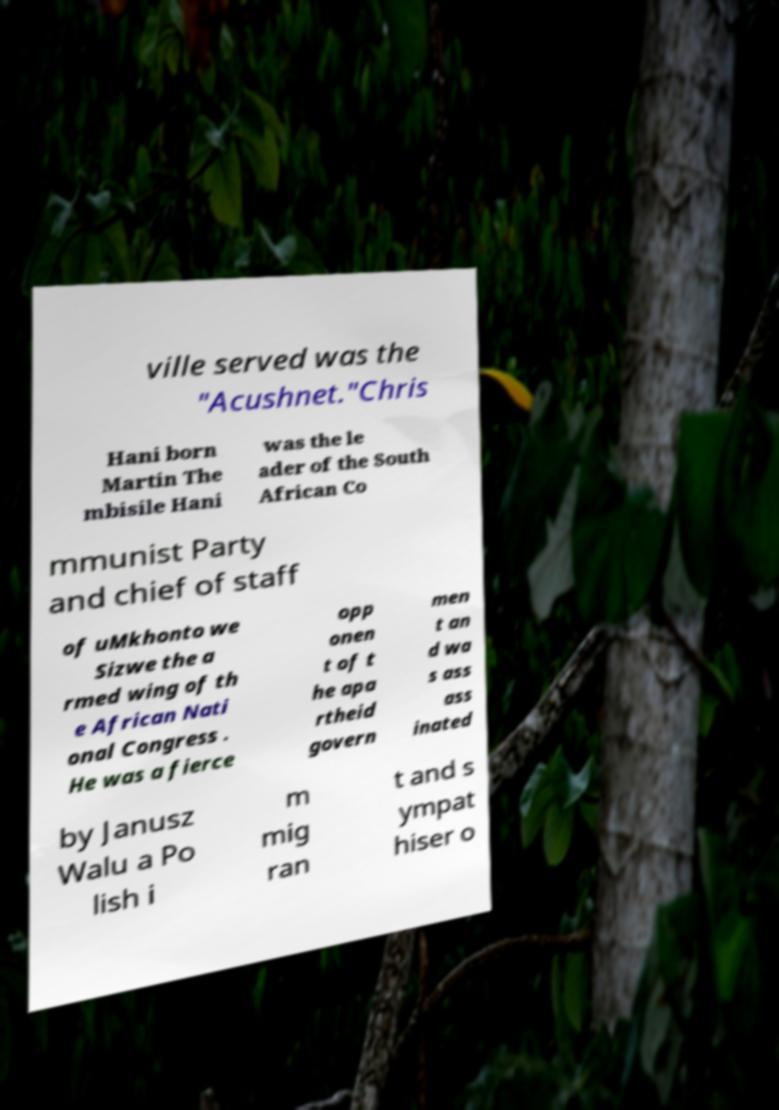Can you accurately transcribe the text from the provided image for me? ville served was the "Acushnet."Chris Hani born Martin The mbisile Hani was the le ader of the South African Co mmunist Party and chief of staff of uMkhonto we Sizwe the a rmed wing of th e African Nati onal Congress . He was a fierce opp onen t of t he apa rtheid govern men t an d wa s ass ass inated by Janusz Walu a Po lish i m mig ran t and s ympat hiser o 